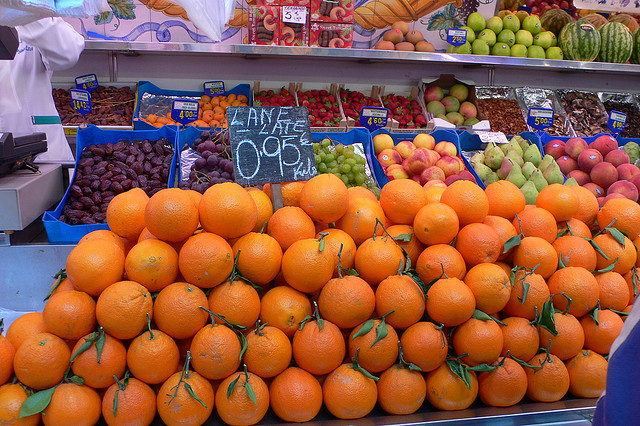Please extract the text content from this image. LANE LATE 0.95 5 460 400 